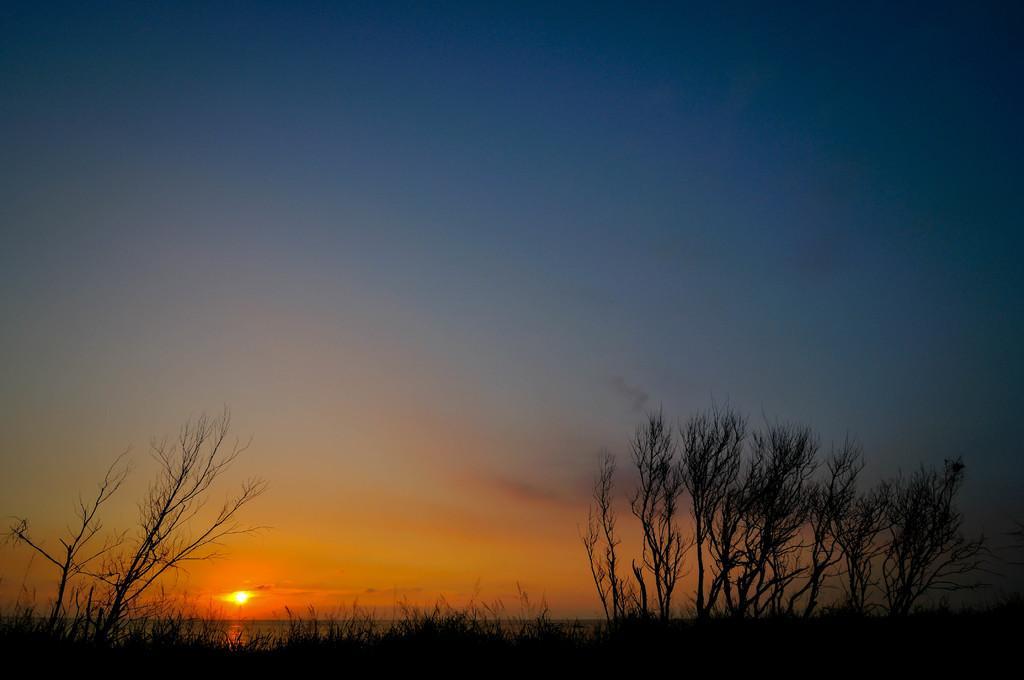Please provide a concise description of this image. In this image, we can see the sun rising in the sky. There are some plants at the bottom of the image. There are trees in the bottom left and in the bottom right of the image. 